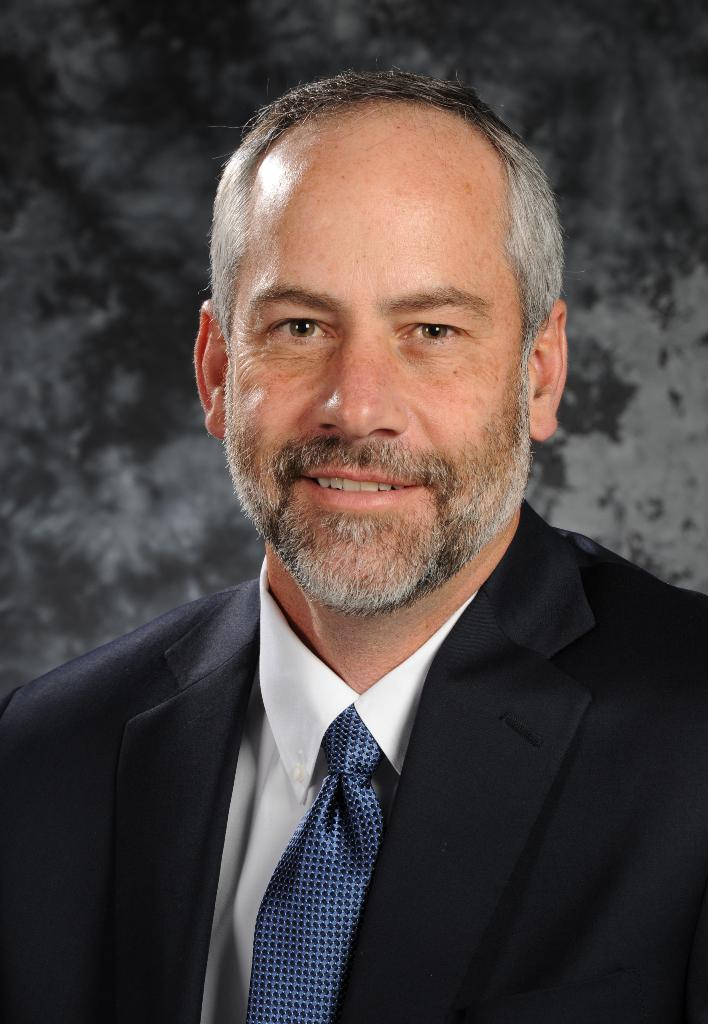What is present in the image? There is a man in the image. How is the man dressed in the image? The man is wearing a formal suit and a tie. How many beds can be seen in the image? There are no beds present in the image; it features a man wearing a formal suit and a tie. What type of insect can be seen on the man's tie in the image? There is no insect, such as a ladybug, present on the man's tie or anywhere else in the image. 